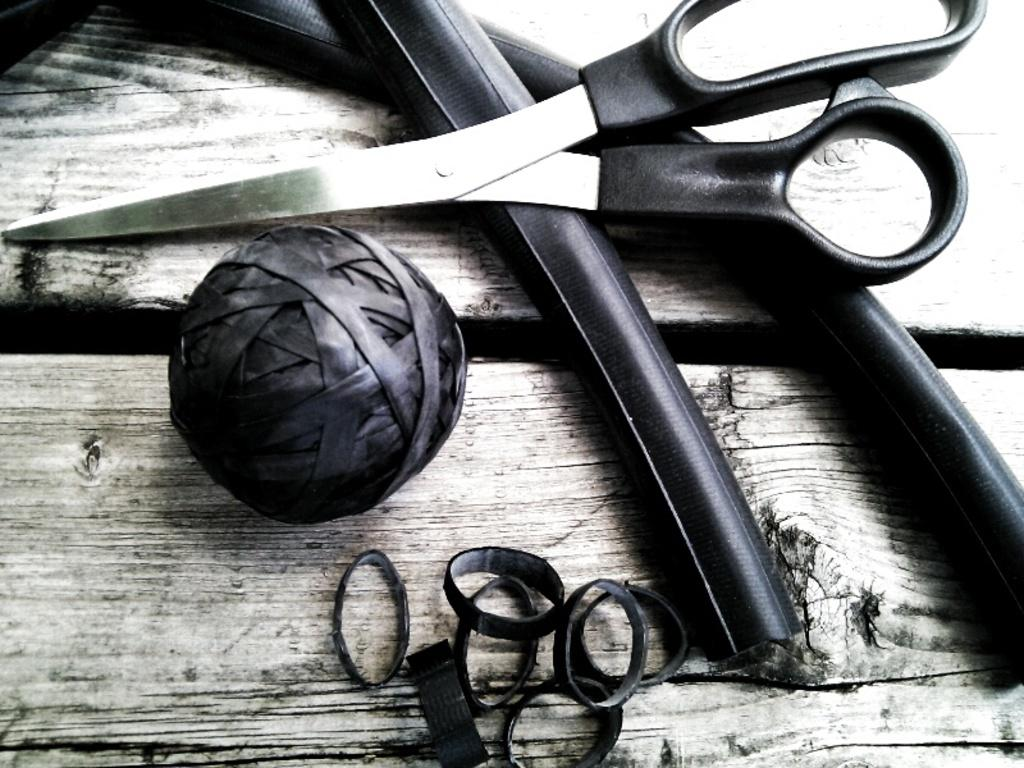What piece of furniture can be seen in the image? There is a table in the image. What object is placed on the table? There is a scissor on the table. What type of material is visible in the image? There are pipes and a thread ball in the image. What type of bands are present in the image? There are bands in the image. What type of road can be seen in the image? There is no road present in the image. What type of jeans are being worn by the person in the image? There is no person or jeans visible in the image. 